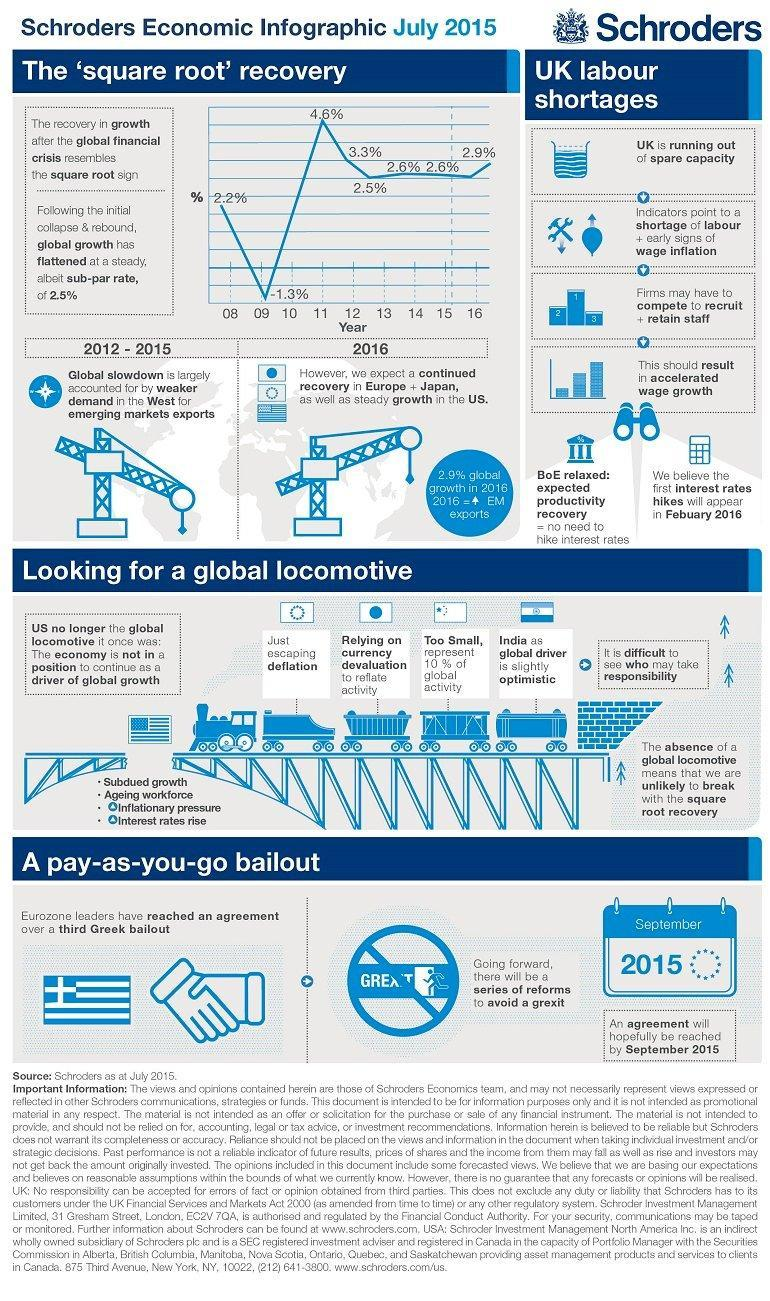Which country wants to reduce the value of currency in order to facilitate the economy, China, India, or Japan?
Answer the question with a short phrase. Japan Which symbol does the graph showing the recovery rate after the economic recession resemble? Square root What was the percentage of recovery in the beginning of the year 2011? 4.6% 